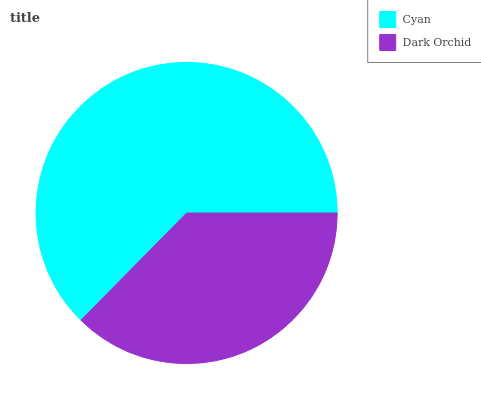Is Dark Orchid the minimum?
Answer yes or no. Yes. Is Cyan the maximum?
Answer yes or no. Yes. Is Dark Orchid the maximum?
Answer yes or no. No. Is Cyan greater than Dark Orchid?
Answer yes or no. Yes. Is Dark Orchid less than Cyan?
Answer yes or no. Yes. Is Dark Orchid greater than Cyan?
Answer yes or no. No. Is Cyan less than Dark Orchid?
Answer yes or no. No. Is Cyan the high median?
Answer yes or no. Yes. Is Dark Orchid the low median?
Answer yes or no. Yes. Is Dark Orchid the high median?
Answer yes or no. No. Is Cyan the low median?
Answer yes or no. No. 